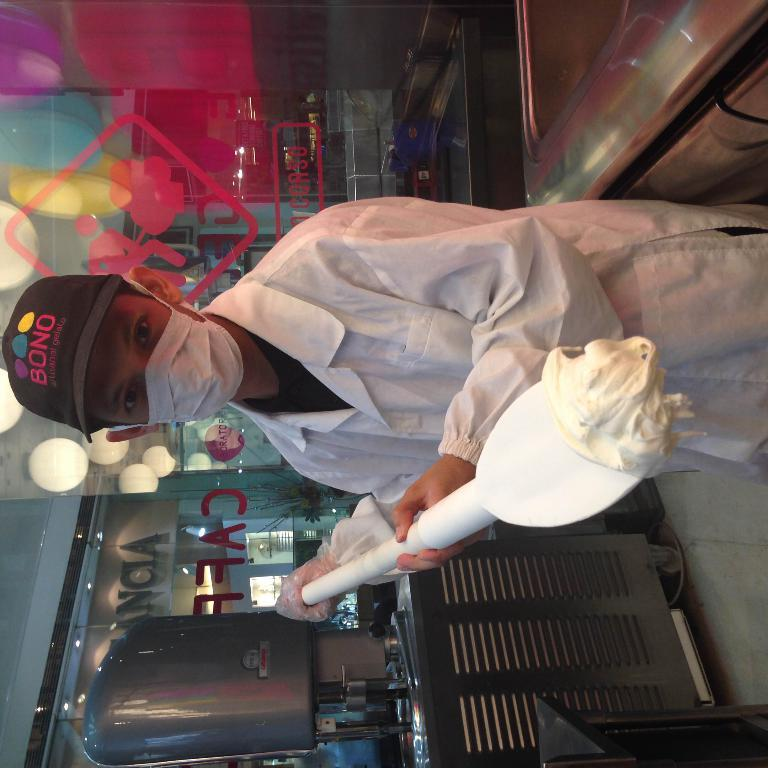Who or what is present in the image? There is a person in the image. What is the person wearing on their face? The person is wearing a mask on their face. What is the person holding in their hands? The person is holding something in their hands. What type of vegetable is being used as a linen in the image? There is no vegetable or linen present in the image. The person is wearing a mask and holding something, but there is no indication of any vegetable or linen being used. 